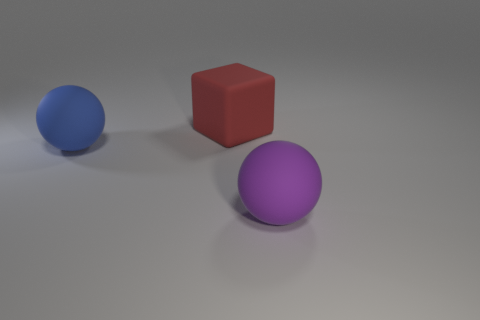Can you describe the lighting in the scene? The lighting in the scene appears to come from a soft overhead source, casting gentle shadows on the floor. The slight glow on the edges of the objects suggests the use of a diffuse light, which softens shadows and reduces contrast, creating a calm and even atmosphere. 